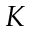<formula> <loc_0><loc_0><loc_500><loc_500>K</formula> 